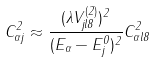<formula> <loc_0><loc_0><loc_500><loc_500>C _ { \alpha j } ^ { 2 } \approx \frac { ( \lambda V _ { j l 8 } ^ { ( 2 ) } ) ^ { 2 } } { ( E _ { \alpha } - E ^ { 0 } _ { j } ) ^ { 2 } } C _ { \alpha l 8 } ^ { 2 }</formula> 